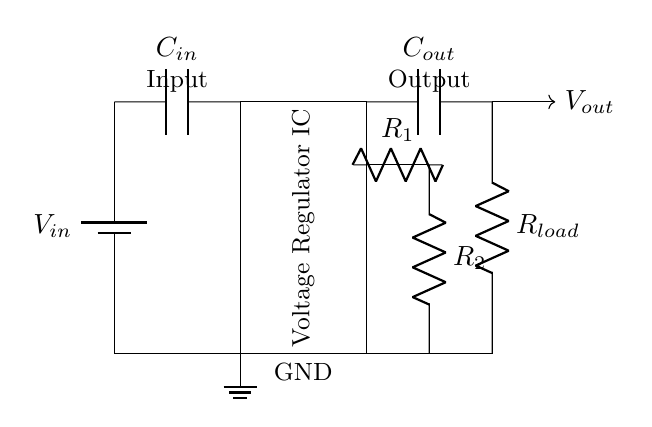What is the purpose of the voltage regulator? The voltage regulator provides a stable output voltage irrespective of variations in the input voltage or load current. This ensures that the e-reader operates reliably.
Answer: Stable output voltage What components are connected in series? The input capacitor is connected in series with the voltage regulator for filtering, and the load resistor is in series with the output capacitor. This configuration allows for proper functioning of the circuit.
Answer: Input capacitor, output capacitor, load resistor What is the value of output voltage? The actual output voltage is not specified in the circuit diagram but should typically be regulated to match the e-reader's requirements. We assume it could be 5 volts for such devices.
Answer: Not specified (assumed 5 volts) How many feedback resistors are present? There are two feedback resistors, R1 and R2, which are used to set the output voltage by providing feedback to the regulator for voltage control.
Answer: Two What connects the feedback resistors to the voltage regulator? The feedback resistors are connected from the output to the ground through the regulator. This allows the regulator to maintain the desired output voltage based on the feedback.
Answer: Ground connection What is the role of the input capacitor? The input capacitor filters the input voltage to smooth out any fluctuations before it reaches the voltage regulator, ensuring stable performance of the circuit.
Answer: Filtering input voltage What does C_out signify in the circuit? C_out is the output capacitor, which stabilizes the output voltage and helps manage transient responses when the load changes. It is crucial for maintaining output stability.
Answer: Stabilizes output voltage 